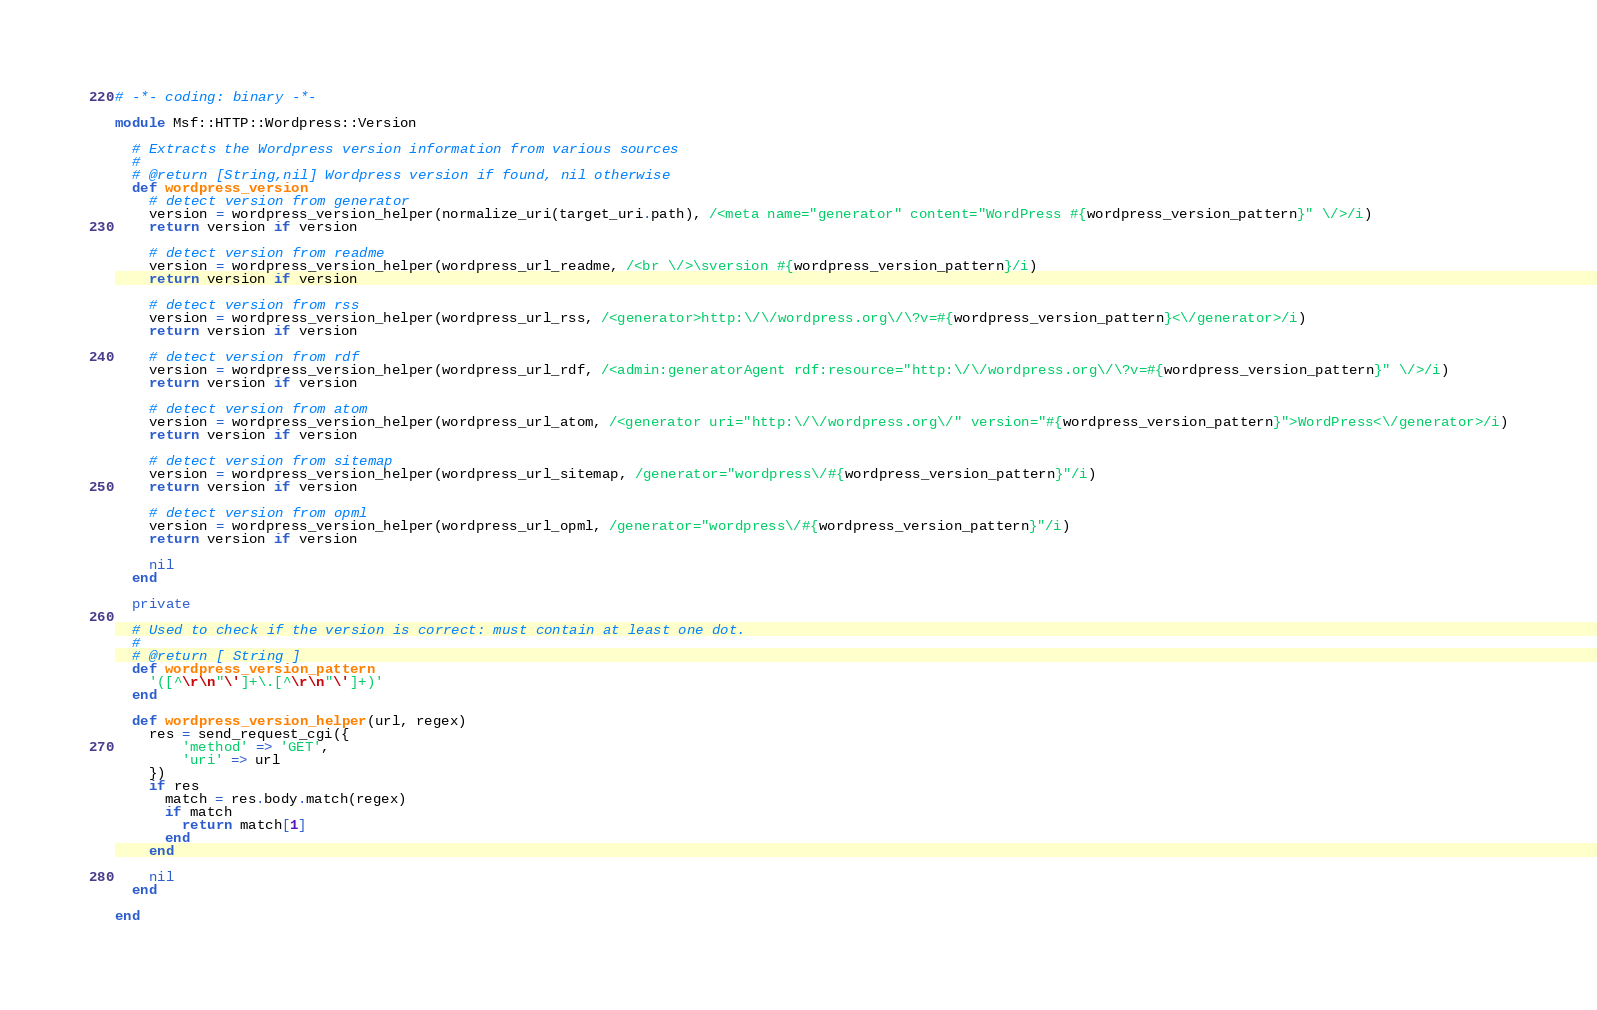Convert code to text. <code><loc_0><loc_0><loc_500><loc_500><_Ruby_># -*- coding: binary -*-

module Msf::HTTP::Wordpress::Version

  # Extracts the Wordpress version information from various sources
  #
  # @return [String,nil] Wordpress version if found, nil otherwise
  def wordpress_version
    # detect version from generator
    version = wordpress_version_helper(normalize_uri(target_uri.path), /<meta name="generator" content="WordPress #{wordpress_version_pattern}" \/>/i)
    return version if version

    # detect version from readme
    version = wordpress_version_helper(wordpress_url_readme, /<br \/>\sversion #{wordpress_version_pattern}/i)
    return version if version

    # detect version from rss
    version = wordpress_version_helper(wordpress_url_rss, /<generator>http:\/\/wordpress.org\/\?v=#{wordpress_version_pattern}<\/generator>/i)
    return version if version

    # detect version from rdf
    version = wordpress_version_helper(wordpress_url_rdf, /<admin:generatorAgent rdf:resource="http:\/\/wordpress.org\/\?v=#{wordpress_version_pattern}" \/>/i)
    return version if version

    # detect version from atom
    version = wordpress_version_helper(wordpress_url_atom, /<generator uri="http:\/\/wordpress.org\/" version="#{wordpress_version_pattern}">WordPress<\/generator>/i)
    return version if version

    # detect version from sitemap
    version = wordpress_version_helper(wordpress_url_sitemap, /generator="wordpress\/#{wordpress_version_pattern}"/i)
    return version if version

    # detect version from opml
    version = wordpress_version_helper(wordpress_url_opml, /generator="wordpress\/#{wordpress_version_pattern}"/i)
    return version if version

    nil
  end

  private

  # Used to check if the version is correct: must contain at least one dot.
  #
  # @return [ String ]
  def wordpress_version_pattern
    '([^\r\n"\']+\.[^\r\n"\']+)'
  end

  def wordpress_version_helper(url, regex)
    res = send_request_cgi({
        'method' => 'GET',
        'uri' => url
    })
    if res
      match = res.body.match(regex)
      if match
        return match[1]
      end
    end

    nil
  end

end
</code> 